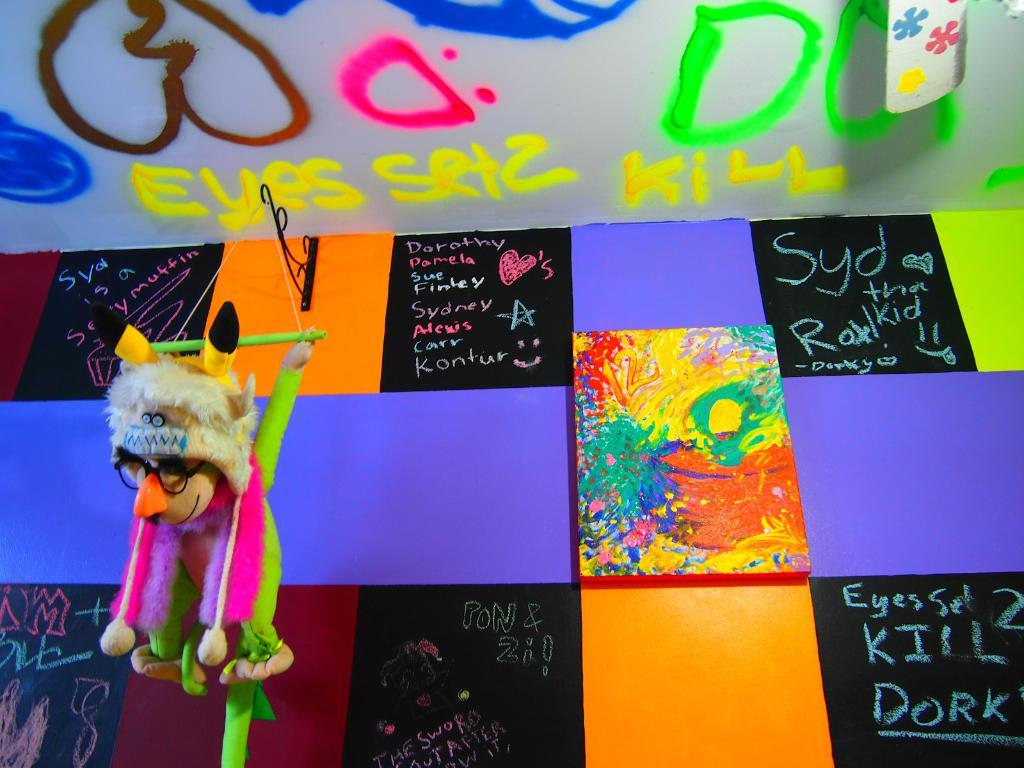<image>
Create a compact narrative representing the image presented. Colored tiles are between chalkboard tiles with people's names on them including Dorothy, Pamela, and Alexis. 